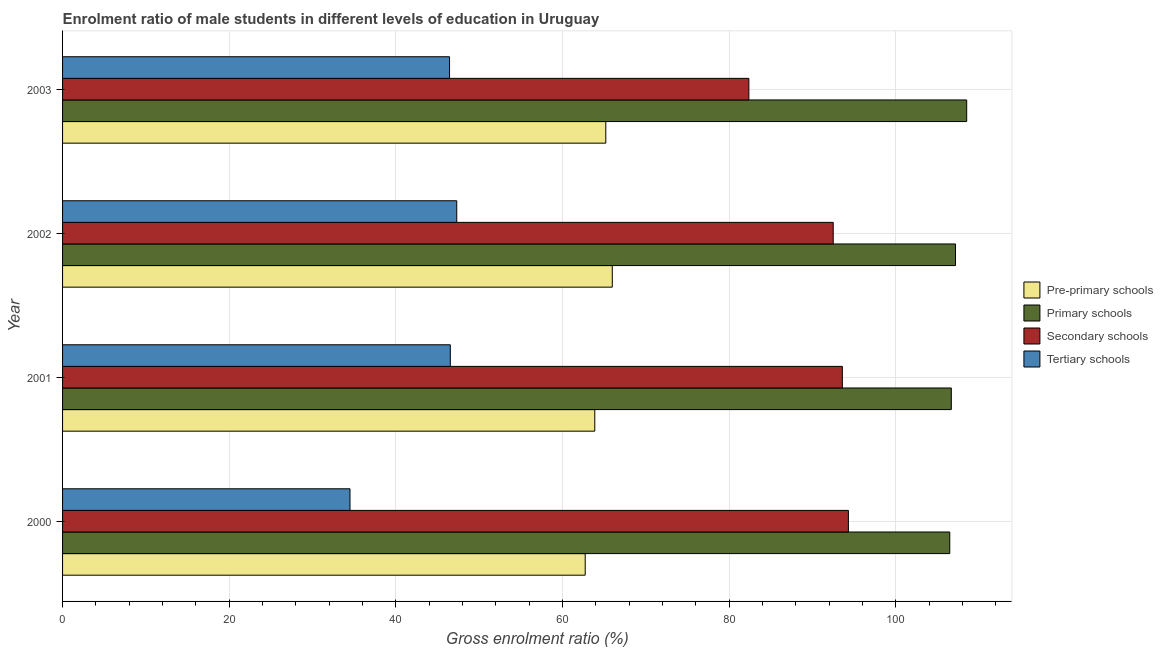Are the number of bars per tick equal to the number of legend labels?
Provide a succinct answer. Yes. Are the number of bars on each tick of the Y-axis equal?
Offer a very short reply. Yes. How many bars are there on the 1st tick from the bottom?
Your answer should be compact. 4. What is the label of the 2nd group of bars from the top?
Your answer should be very brief. 2002. What is the gross enrolment ratio(female) in tertiary schools in 2002?
Give a very brief answer. 47.3. Across all years, what is the maximum gross enrolment ratio(female) in primary schools?
Your answer should be very brief. 108.49. Across all years, what is the minimum gross enrolment ratio(female) in secondary schools?
Provide a succinct answer. 82.35. What is the total gross enrolment ratio(female) in secondary schools in the graph?
Keep it short and to the point. 362.69. What is the difference between the gross enrolment ratio(female) in pre-primary schools in 2000 and that in 2002?
Offer a terse response. -3.25. What is the difference between the gross enrolment ratio(female) in pre-primary schools in 2000 and the gross enrolment ratio(female) in tertiary schools in 2002?
Give a very brief answer. 15.41. What is the average gross enrolment ratio(female) in pre-primary schools per year?
Make the answer very short. 64.43. In the year 2002, what is the difference between the gross enrolment ratio(female) in tertiary schools and gross enrolment ratio(female) in secondary schools?
Ensure brevity in your answer.  -45.17. What is the ratio of the gross enrolment ratio(female) in tertiary schools in 2000 to that in 2003?
Make the answer very short. 0.74. Is the difference between the gross enrolment ratio(female) in pre-primary schools in 2001 and 2003 greater than the difference between the gross enrolment ratio(female) in tertiary schools in 2001 and 2003?
Provide a succinct answer. No. What is the difference between the highest and the second highest gross enrolment ratio(female) in primary schools?
Offer a terse response. 1.34. What is the difference between the highest and the lowest gross enrolment ratio(female) in secondary schools?
Your answer should be very brief. 11.94. In how many years, is the gross enrolment ratio(female) in primary schools greater than the average gross enrolment ratio(female) in primary schools taken over all years?
Keep it short and to the point. 1. Is the sum of the gross enrolment ratio(female) in pre-primary schools in 2000 and 2003 greater than the maximum gross enrolment ratio(female) in primary schools across all years?
Provide a succinct answer. Yes. Is it the case that in every year, the sum of the gross enrolment ratio(female) in primary schools and gross enrolment ratio(female) in secondary schools is greater than the sum of gross enrolment ratio(female) in pre-primary schools and gross enrolment ratio(female) in tertiary schools?
Provide a short and direct response. Yes. What does the 4th bar from the top in 2000 represents?
Your response must be concise. Pre-primary schools. What does the 3rd bar from the bottom in 2002 represents?
Ensure brevity in your answer.  Secondary schools. Is it the case that in every year, the sum of the gross enrolment ratio(female) in pre-primary schools and gross enrolment ratio(female) in primary schools is greater than the gross enrolment ratio(female) in secondary schools?
Offer a very short reply. Yes. Are all the bars in the graph horizontal?
Ensure brevity in your answer.  Yes. How many years are there in the graph?
Offer a very short reply. 4. Does the graph contain any zero values?
Provide a short and direct response. No. Does the graph contain grids?
Your answer should be compact. Yes. How many legend labels are there?
Offer a very short reply. 4. How are the legend labels stacked?
Provide a short and direct response. Vertical. What is the title of the graph?
Ensure brevity in your answer.  Enrolment ratio of male students in different levels of education in Uruguay. What is the label or title of the X-axis?
Make the answer very short. Gross enrolment ratio (%). What is the label or title of the Y-axis?
Give a very brief answer. Year. What is the Gross enrolment ratio (%) in Pre-primary schools in 2000?
Provide a short and direct response. 62.71. What is the Gross enrolment ratio (%) in Primary schools in 2000?
Offer a very short reply. 106.46. What is the Gross enrolment ratio (%) in Secondary schools in 2000?
Provide a short and direct response. 94.29. What is the Gross enrolment ratio (%) of Tertiary schools in 2000?
Your answer should be very brief. 34.49. What is the Gross enrolment ratio (%) in Pre-primary schools in 2001?
Offer a terse response. 63.86. What is the Gross enrolment ratio (%) of Primary schools in 2001?
Provide a succinct answer. 106.64. What is the Gross enrolment ratio (%) in Secondary schools in 2001?
Your answer should be very brief. 93.57. What is the Gross enrolment ratio (%) of Tertiary schools in 2001?
Make the answer very short. 46.53. What is the Gross enrolment ratio (%) of Pre-primary schools in 2002?
Your answer should be very brief. 65.96. What is the Gross enrolment ratio (%) of Primary schools in 2002?
Provide a short and direct response. 107.15. What is the Gross enrolment ratio (%) of Secondary schools in 2002?
Make the answer very short. 92.47. What is the Gross enrolment ratio (%) of Tertiary schools in 2002?
Your answer should be compact. 47.3. What is the Gross enrolment ratio (%) in Pre-primary schools in 2003?
Provide a succinct answer. 65.18. What is the Gross enrolment ratio (%) in Primary schools in 2003?
Your answer should be compact. 108.49. What is the Gross enrolment ratio (%) of Secondary schools in 2003?
Give a very brief answer. 82.35. What is the Gross enrolment ratio (%) of Tertiary schools in 2003?
Your answer should be very brief. 46.44. Across all years, what is the maximum Gross enrolment ratio (%) in Pre-primary schools?
Offer a terse response. 65.96. Across all years, what is the maximum Gross enrolment ratio (%) in Primary schools?
Your answer should be compact. 108.49. Across all years, what is the maximum Gross enrolment ratio (%) of Secondary schools?
Your answer should be compact. 94.29. Across all years, what is the maximum Gross enrolment ratio (%) of Tertiary schools?
Provide a short and direct response. 47.3. Across all years, what is the minimum Gross enrolment ratio (%) of Pre-primary schools?
Keep it short and to the point. 62.71. Across all years, what is the minimum Gross enrolment ratio (%) in Primary schools?
Your answer should be very brief. 106.46. Across all years, what is the minimum Gross enrolment ratio (%) of Secondary schools?
Give a very brief answer. 82.35. Across all years, what is the minimum Gross enrolment ratio (%) in Tertiary schools?
Your response must be concise. 34.49. What is the total Gross enrolment ratio (%) in Pre-primary schools in the graph?
Ensure brevity in your answer.  257.72. What is the total Gross enrolment ratio (%) in Primary schools in the graph?
Provide a succinct answer. 428.73. What is the total Gross enrolment ratio (%) of Secondary schools in the graph?
Ensure brevity in your answer.  362.69. What is the total Gross enrolment ratio (%) of Tertiary schools in the graph?
Your answer should be very brief. 174.75. What is the difference between the Gross enrolment ratio (%) of Pre-primary schools in 2000 and that in 2001?
Offer a very short reply. -1.15. What is the difference between the Gross enrolment ratio (%) in Primary schools in 2000 and that in 2001?
Ensure brevity in your answer.  -0.18. What is the difference between the Gross enrolment ratio (%) of Secondary schools in 2000 and that in 2001?
Make the answer very short. 0.73. What is the difference between the Gross enrolment ratio (%) of Tertiary schools in 2000 and that in 2001?
Provide a succinct answer. -12.04. What is the difference between the Gross enrolment ratio (%) in Pre-primary schools in 2000 and that in 2002?
Your response must be concise. -3.25. What is the difference between the Gross enrolment ratio (%) in Primary schools in 2000 and that in 2002?
Your response must be concise. -0.69. What is the difference between the Gross enrolment ratio (%) in Secondary schools in 2000 and that in 2002?
Keep it short and to the point. 1.82. What is the difference between the Gross enrolment ratio (%) in Tertiary schools in 2000 and that in 2002?
Provide a short and direct response. -12.81. What is the difference between the Gross enrolment ratio (%) in Pre-primary schools in 2000 and that in 2003?
Your answer should be very brief. -2.47. What is the difference between the Gross enrolment ratio (%) in Primary schools in 2000 and that in 2003?
Offer a terse response. -2.03. What is the difference between the Gross enrolment ratio (%) of Secondary schools in 2000 and that in 2003?
Offer a very short reply. 11.94. What is the difference between the Gross enrolment ratio (%) in Tertiary schools in 2000 and that in 2003?
Make the answer very short. -11.95. What is the difference between the Gross enrolment ratio (%) of Pre-primary schools in 2001 and that in 2002?
Offer a terse response. -2.1. What is the difference between the Gross enrolment ratio (%) in Primary schools in 2001 and that in 2002?
Offer a very short reply. -0.5. What is the difference between the Gross enrolment ratio (%) in Secondary schools in 2001 and that in 2002?
Ensure brevity in your answer.  1.1. What is the difference between the Gross enrolment ratio (%) in Tertiary schools in 2001 and that in 2002?
Offer a very short reply. -0.77. What is the difference between the Gross enrolment ratio (%) of Pre-primary schools in 2001 and that in 2003?
Your answer should be very brief. -1.32. What is the difference between the Gross enrolment ratio (%) in Primary schools in 2001 and that in 2003?
Offer a very short reply. -1.85. What is the difference between the Gross enrolment ratio (%) in Secondary schools in 2001 and that in 2003?
Your answer should be compact. 11.22. What is the difference between the Gross enrolment ratio (%) in Tertiary schools in 2001 and that in 2003?
Ensure brevity in your answer.  0.09. What is the difference between the Gross enrolment ratio (%) of Pre-primary schools in 2002 and that in 2003?
Provide a succinct answer. 0.78. What is the difference between the Gross enrolment ratio (%) of Primary schools in 2002 and that in 2003?
Your response must be concise. -1.34. What is the difference between the Gross enrolment ratio (%) in Secondary schools in 2002 and that in 2003?
Offer a very short reply. 10.12. What is the difference between the Gross enrolment ratio (%) in Tertiary schools in 2002 and that in 2003?
Your answer should be compact. 0.86. What is the difference between the Gross enrolment ratio (%) in Pre-primary schools in 2000 and the Gross enrolment ratio (%) in Primary schools in 2001?
Give a very brief answer. -43.93. What is the difference between the Gross enrolment ratio (%) in Pre-primary schools in 2000 and the Gross enrolment ratio (%) in Secondary schools in 2001?
Your response must be concise. -30.86. What is the difference between the Gross enrolment ratio (%) in Pre-primary schools in 2000 and the Gross enrolment ratio (%) in Tertiary schools in 2001?
Provide a short and direct response. 16.19. What is the difference between the Gross enrolment ratio (%) of Primary schools in 2000 and the Gross enrolment ratio (%) of Secondary schools in 2001?
Your response must be concise. 12.89. What is the difference between the Gross enrolment ratio (%) in Primary schools in 2000 and the Gross enrolment ratio (%) in Tertiary schools in 2001?
Offer a terse response. 59.93. What is the difference between the Gross enrolment ratio (%) in Secondary schools in 2000 and the Gross enrolment ratio (%) in Tertiary schools in 2001?
Provide a short and direct response. 47.77. What is the difference between the Gross enrolment ratio (%) in Pre-primary schools in 2000 and the Gross enrolment ratio (%) in Primary schools in 2002?
Your answer should be very brief. -44.43. What is the difference between the Gross enrolment ratio (%) in Pre-primary schools in 2000 and the Gross enrolment ratio (%) in Secondary schools in 2002?
Ensure brevity in your answer.  -29.76. What is the difference between the Gross enrolment ratio (%) in Pre-primary schools in 2000 and the Gross enrolment ratio (%) in Tertiary schools in 2002?
Ensure brevity in your answer.  15.41. What is the difference between the Gross enrolment ratio (%) of Primary schools in 2000 and the Gross enrolment ratio (%) of Secondary schools in 2002?
Keep it short and to the point. 13.98. What is the difference between the Gross enrolment ratio (%) of Primary schools in 2000 and the Gross enrolment ratio (%) of Tertiary schools in 2002?
Offer a terse response. 59.16. What is the difference between the Gross enrolment ratio (%) in Secondary schools in 2000 and the Gross enrolment ratio (%) in Tertiary schools in 2002?
Give a very brief answer. 47. What is the difference between the Gross enrolment ratio (%) in Pre-primary schools in 2000 and the Gross enrolment ratio (%) in Primary schools in 2003?
Give a very brief answer. -45.78. What is the difference between the Gross enrolment ratio (%) in Pre-primary schools in 2000 and the Gross enrolment ratio (%) in Secondary schools in 2003?
Ensure brevity in your answer.  -19.64. What is the difference between the Gross enrolment ratio (%) in Pre-primary schools in 2000 and the Gross enrolment ratio (%) in Tertiary schools in 2003?
Provide a short and direct response. 16.28. What is the difference between the Gross enrolment ratio (%) in Primary schools in 2000 and the Gross enrolment ratio (%) in Secondary schools in 2003?
Provide a short and direct response. 24.11. What is the difference between the Gross enrolment ratio (%) in Primary schools in 2000 and the Gross enrolment ratio (%) in Tertiary schools in 2003?
Make the answer very short. 60.02. What is the difference between the Gross enrolment ratio (%) of Secondary schools in 2000 and the Gross enrolment ratio (%) of Tertiary schools in 2003?
Your answer should be very brief. 47.86. What is the difference between the Gross enrolment ratio (%) in Pre-primary schools in 2001 and the Gross enrolment ratio (%) in Primary schools in 2002?
Provide a short and direct response. -43.28. What is the difference between the Gross enrolment ratio (%) of Pre-primary schools in 2001 and the Gross enrolment ratio (%) of Secondary schools in 2002?
Offer a very short reply. -28.61. What is the difference between the Gross enrolment ratio (%) of Pre-primary schools in 2001 and the Gross enrolment ratio (%) of Tertiary schools in 2002?
Give a very brief answer. 16.56. What is the difference between the Gross enrolment ratio (%) of Primary schools in 2001 and the Gross enrolment ratio (%) of Secondary schools in 2002?
Provide a succinct answer. 14.17. What is the difference between the Gross enrolment ratio (%) of Primary schools in 2001 and the Gross enrolment ratio (%) of Tertiary schools in 2002?
Ensure brevity in your answer.  59.34. What is the difference between the Gross enrolment ratio (%) of Secondary schools in 2001 and the Gross enrolment ratio (%) of Tertiary schools in 2002?
Ensure brevity in your answer.  46.27. What is the difference between the Gross enrolment ratio (%) of Pre-primary schools in 2001 and the Gross enrolment ratio (%) of Primary schools in 2003?
Give a very brief answer. -44.63. What is the difference between the Gross enrolment ratio (%) of Pre-primary schools in 2001 and the Gross enrolment ratio (%) of Secondary schools in 2003?
Make the answer very short. -18.49. What is the difference between the Gross enrolment ratio (%) in Pre-primary schools in 2001 and the Gross enrolment ratio (%) in Tertiary schools in 2003?
Your answer should be very brief. 17.43. What is the difference between the Gross enrolment ratio (%) in Primary schools in 2001 and the Gross enrolment ratio (%) in Secondary schools in 2003?
Ensure brevity in your answer.  24.29. What is the difference between the Gross enrolment ratio (%) in Primary schools in 2001 and the Gross enrolment ratio (%) in Tertiary schools in 2003?
Keep it short and to the point. 60.21. What is the difference between the Gross enrolment ratio (%) in Secondary schools in 2001 and the Gross enrolment ratio (%) in Tertiary schools in 2003?
Your response must be concise. 47.13. What is the difference between the Gross enrolment ratio (%) of Pre-primary schools in 2002 and the Gross enrolment ratio (%) of Primary schools in 2003?
Provide a succinct answer. -42.53. What is the difference between the Gross enrolment ratio (%) of Pre-primary schools in 2002 and the Gross enrolment ratio (%) of Secondary schools in 2003?
Keep it short and to the point. -16.39. What is the difference between the Gross enrolment ratio (%) in Pre-primary schools in 2002 and the Gross enrolment ratio (%) in Tertiary schools in 2003?
Offer a terse response. 19.53. What is the difference between the Gross enrolment ratio (%) in Primary schools in 2002 and the Gross enrolment ratio (%) in Secondary schools in 2003?
Offer a very short reply. 24.8. What is the difference between the Gross enrolment ratio (%) in Primary schools in 2002 and the Gross enrolment ratio (%) in Tertiary schools in 2003?
Keep it short and to the point. 60.71. What is the difference between the Gross enrolment ratio (%) of Secondary schools in 2002 and the Gross enrolment ratio (%) of Tertiary schools in 2003?
Give a very brief answer. 46.04. What is the average Gross enrolment ratio (%) of Pre-primary schools per year?
Make the answer very short. 64.43. What is the average Gross enrolment ratio (%) of Primary schools per year?
Offer a very short reply. 107.18. What is the average Gross enrolment ratio (%) in Secondary schools per year?
Give a very brief answer. 90.67. What is the average Gross enrolment ratio (%) of Tertiary schools per year?
Your answer should be compact. 43.69. In the year 2000, what is the difference between the Gross enrolment ratio (%) of Pre-primary schools and Gross enrolment ratio (%) of Primary schools?
Make the answer very short. -43.74. In the year 2000, what is the difference between the Gross enrolment ratio (%) of Pre-primary schools and Gross enrolment ratio (%) of Secondary schools?
Keep it short and to the point. -31.58. In the year 2000, what is the difference between the Gross enrolment ratio (%) of Pre-primary schools and Gross enrolment ratio (%) of Tertiary schools?
Your answer should be very brief. 28.22. In the year 2000, what is the difference between the Gross enrolment ratio (%) of Primary schools and Gross enrolment ratio (%) of Secondary schools?
Offer a terse response. 12.16. In the year 2000, what is the difference between the Gross enrolment ratio (%) of Primary schools and Gross enrolment ratio (%) of Tertiary schools?
Your answer should be very brief. 71.97. In the year 2000, what is the difference between the Gross enrolment ratio (%) of Secondary schools and Gross enrolment ratio (%) of Tertiary schools?
Offer a very short reply. 59.8. In the year 2001, what is the difference between the Gross enrolment ratio (%) in Pre-primary schools and Gross enrolment ratio (%) in Primary schools?
Make the answer very short. -42.78. In the year 2001, what is the difference between the Gross enrolment ratio (%) in Pre-primary schools and Gross enrolment ratio (%) in Secondary schools?
Give a very brief answer. -29.71. In the year 2001, what is the difference between the Gross enrolment ratio (%) in Pre-primary schools and Gross enrolment ratio (%) in Tertiary schools?
Your answer should be compact. 17.33. In the year 2001, what is the difference between the Gross enrolment ratio (%) of Primary schools and Gross enrolment ratio (%) of Secondary schools?
Offer a very short reply. 13.07. In the year 2001, what is the difference between the Gross enrolment ratio (%) in Primary schools and Gross enrolment ratio (%) in Tertiary schools?
Provide a short and direct response. 60.12. In the year 2001, what is the difference between the Gross enrolment ratio (%) of Secondary schools and Gross enrolment ratio (%) of Tertiary schools?
Your answer should be compact. 47.04. In the year 2002, what is the difference between the Gross enrolment ratio (%) in Pre-primary schools and Gross enrolment ratio (%) in Primary schools?
Offer a terse response. -41.18. In the year 2002, what is the difference between the Gross enrolment ratio (%) of Pre-primary schools and Gross enrolment ratio (%) of Secondary schools?
Provide a succinct answer. -26.51. In the year 2002, what is the difference between the Gross enrolment ratio (%) of Pre-primary schools and Gross enrolment ratio (%) of Tertiary schools?
Provide a short and direct response. 18.66. In the year 2002, what is the difference between the Gross enrolment ratio (%) in Primary schools and Gross enrolment ratio (%) in Secondary schools?
Make the answer very short. 14.67. In the year 2002, what is the difference between the Gross enrolment ratio (%) of Primary schools and Gross enrolment ratio (%) of Tertiary schools?
Provide a succinct answer. 59.85. In the year 2002, what is the difference between the Gross enrolment ratio (%) in Secondary schools and Gross enrolment ratio (%) in Tertiary schools?
Your answer should be compact. 45.17. In the year 2003, what is the difference between the Gross enrolment ratio (%) in Pre-primary schools and Gross enrolment ratio (%) in Primary schools?
Your answer should be compact. -43.31. In the year 2003, what is the difference between the Gross enrolment ratio (%) in Pre-primary schools and Gross enrolment ratio (%) in Secondary schools?
Offer a very short reply. -17.17. In the year 2003, what is the difference between the Gross enrolment ratio (%) in Pre-primary schools and Gross enrolment ratio (%) in Tertiary schools?
Provide a succinct answer. 18.75. In the year 2003, what is the difference between the Gross enrolment ratio (%) of Primary schools and Gross enrolment ratio (%) of Secondary schools?
Give a very brief answer. 26.14. In the year 2003, what is the difference between the Gross enrolment ratio (%) of Primary schools and Gross enrolment ratio (%) of Tertiary schools?
Provide a succinct answer. 62.05. In the year 2003, what is the difference between the Gross enrolment ratio (%) in Secondary schools and Gross enrolment ratio (%) in Tertiary schools?
Give a very brief answer. 35.91. What is the ratio of the Gross enrolment ratio (%) in Primary schools in 2000 to that in 2001?
Offer a very short reply. 1. What is the ratio of the Gross enrolment ratio (%) of Secondary schools in 2000 to that in 2001?
Make the answer very short. 1.01. What is the ratio of the Gross enrolment ratio (%) in Tertiary schools in 2000 to that in 2001?
Ensure brevity in your answer.  0.74. What is the ratio of the Gross enrolment ratio (%) in Pre-primary schools in 2000 to that in 2002?
Your answer should be compact. 0.95. What is the ratio of the Gross enrolment ratio (%) in Secondary schools in 2000 to that in 2002?
Offer a very short reply. 1.02. What is the ratio of the Gross enrolment ratio (%) of Tertiary schools in 2000 to that in 2002?
Keep it short and to the point. 0.73. What is the ratio of the Gross enrolment ratio (%) of Pre-primary schools in 2000 to that in 2003?
Ensure brevity in your answer.  0.96. What is the ratio of the Gross enrolment ratio (%) in Primary schools in 2000 to that in 2003?
Give a very brief answer. 0.98. What is the ratio of the Gross enrolment ratio (%) of Secondary schools in 2000 to that in 2003?
Provide a succinct answer. 1.15. What is the ratio of the Gross enrolment ratio (%) of Tertiary schools in 2000 to that in 2003?
Provide a succinct answer. 0.74. What is the ratio of the Gross enrolment ratio (%) of Pre-primary schools in 2001 to that in 2002?
Give a very brief answer. 0.97. What is the ratio of the Gross enrolment ratio (%) of Primary schools in 2001 to that in 2002?
Provide a succinct answer. 1. What is the ratio of the Gross enrolment ratio (%) in Secondary schools in 2001 to that in 2002?
Ensure brevity in your answer.  1.01. What is the ratio of the Gross enrolment ratio (%) in Tertiary schools in 2001 to that in 2002?
Give a very brief answer. 0.98. What is the ratio of the Gross enrolment ratio (%) of Pre-primary schools in 2001 to that in 2003?
Your answer should be compact. 0.98. What is the ratio of the Gross enrolment ratio (%) in Primary schools in 2001 to that in 2003?
Provide a short and direct response. 0.98. What is the ratio of the Gross enrolment ratio (%) of Secondary schools in 2001 to that in 2003?
Offer a terse response. 1.14. What is the ratio of the Gross enrolment ratio (%) in Pre-primary schools in 2002 to that in 2003?
Make the answer very short. 1.01. What is the ratio of the Gross enrolment ratio (%) of Primary schools in 2002 to that in 2003?
Provide a succinct answer. 0.99. What is the ratio of the Gross enrolment ratio (%) of Secondary schools in 2002 to that in 2003?
Ensure brevity in your answer.  1.12. What is the ratio of the Gross enrolment ratio (%) in Tertiary schools in 2002 to that in 2003?
Your answer should be very brief. 1.02. What is the difference between the highest and the second highest Gross enrolment ratio (%) in Pre-primary schools?
Provide a short and direct response. 0.78. What is the difference between the highest and the second highest Gross enrolment ratio (%) in Primary schools?
Your answer should be very brief. 1.34. What is the difference between the highest and the second highest Gross enrolment ratio (%) in Secondary schools?
Keep it short and to the point. 0.73. What is the difference between the highest and the second highest Gross enrolment ratio (%) of Tertiary schools?
Provide a succinct answer. 0.77. What is the difference between the highest and the lowest Gross enrolment ratio (%) in Pre-primary schools?
Your answer should be very brief. 3.25. What is the difference between the highest and the lowest Gross enrolment ratio (%) of Primary schools?
Make the answer very short. 2.03. What is the difference between the highest and the lowest Gross enrolment ratio (%) of Secondary schools?
Your answer should be very brief. 11.94. What is the difference between the highest and the lowest Gross enrolment ratio (%) of Tertiary schools?
Keep it short and to the point. 12.81. 